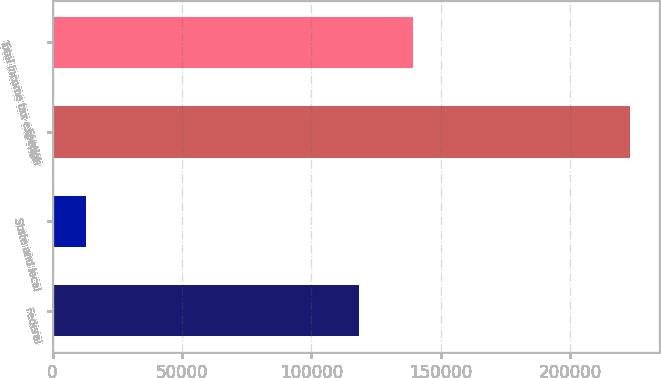<chart> <loc_0><loc_0><loc_500><loc_500><bar_chart><fcel>Federal<fcel>State and local<fcel>Foreign<fcel>Total income tax expense<nl><fcel>118387<fcel>13124<fcel>223143<fcel>139389<nl></chart> 